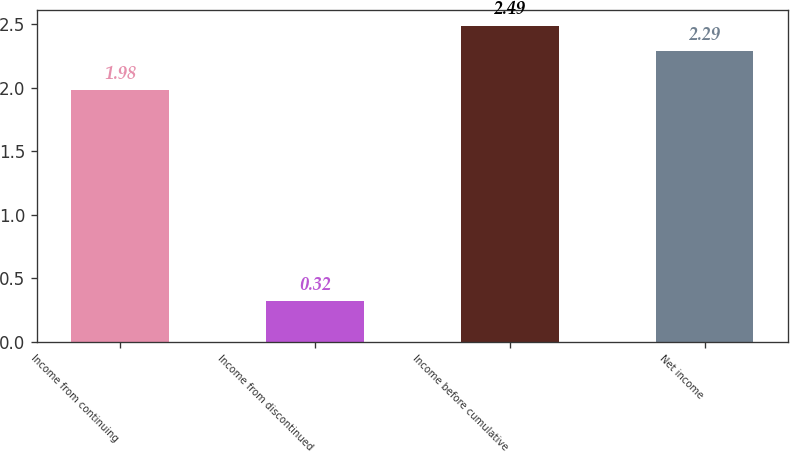Convert chart to OTSL. <chart><loc_0><loc_0><loc_500><loc_500><bar_chart><fcel>Income from continuing<fcel>Income from discontinued<fcel>Income before cumulative<fcel>Net income<nl><fcel>1.98<fcel>0.32<fcel>2.49<fcel>2.29<nl></chart> 